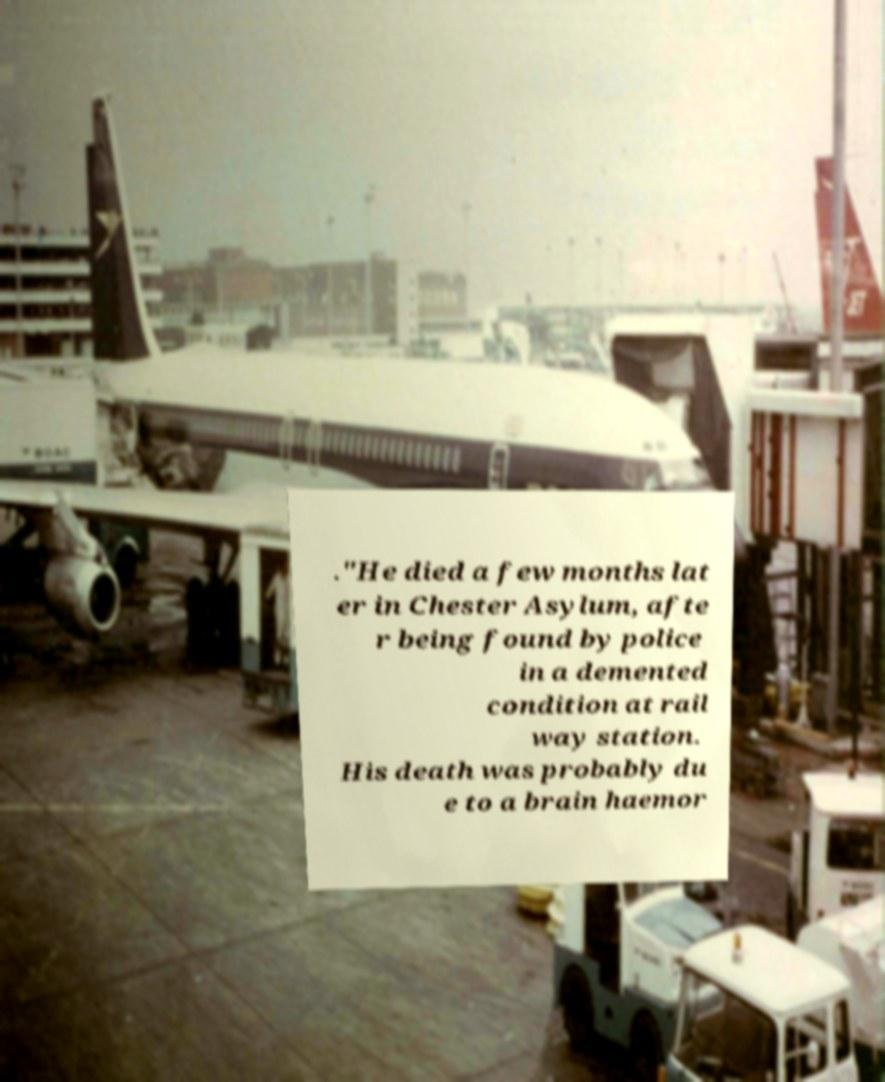Can you accurately transcribe the text from the provided image for me? ."He died a few months lat er in Chester Asylum, afte r being found by police in a demented condition at rail way station. His death was probably du e to a brain haemor 